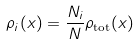<formula> <loc_0><loc_0><loc_500><loc_500>\rho _ { i } ( x ) = \frac { N _ { i } } N \rho _ { \text {tot} } ( x )</formula> 